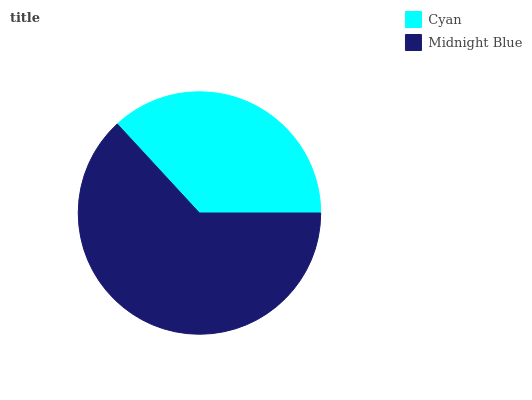Is Cyan the minimum?
Answer yes or no. Yes. Is Midnight Blue the maximum?
Answer yes or no. Yes. Is Midnight Blue the minimum?
Answer yes or no. No. Is Midnight Blue greater than Cyan?
Answer yes or no. Yes. Is Cyan less than Midnight Blue?
Answer yes or no. Yes. Is Cyan greater than Midnight Blue?
Answer yes or no. No. Is Midnight Blue less than Cyan?
Answer yes or no. No. Is Midnight Blue the high median?
Answer yes or no. Yes. Is Cyan the low median?
Answer yes or no. Yes. Is Cyan the high median?
Answer yes or no. No. Is Midnight Blue the low median?
Answer yes or no. No. 